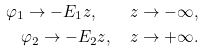<formula> <loc_0><loc_0><loc_500><loc_500>\varphi _ { 1 } \to - E _ { 1 } z , \quad z \to - \infty , \\ \varphi _ { 2 } \to - E _ { 2 } z , \quad z \to + \infty .</formula> 